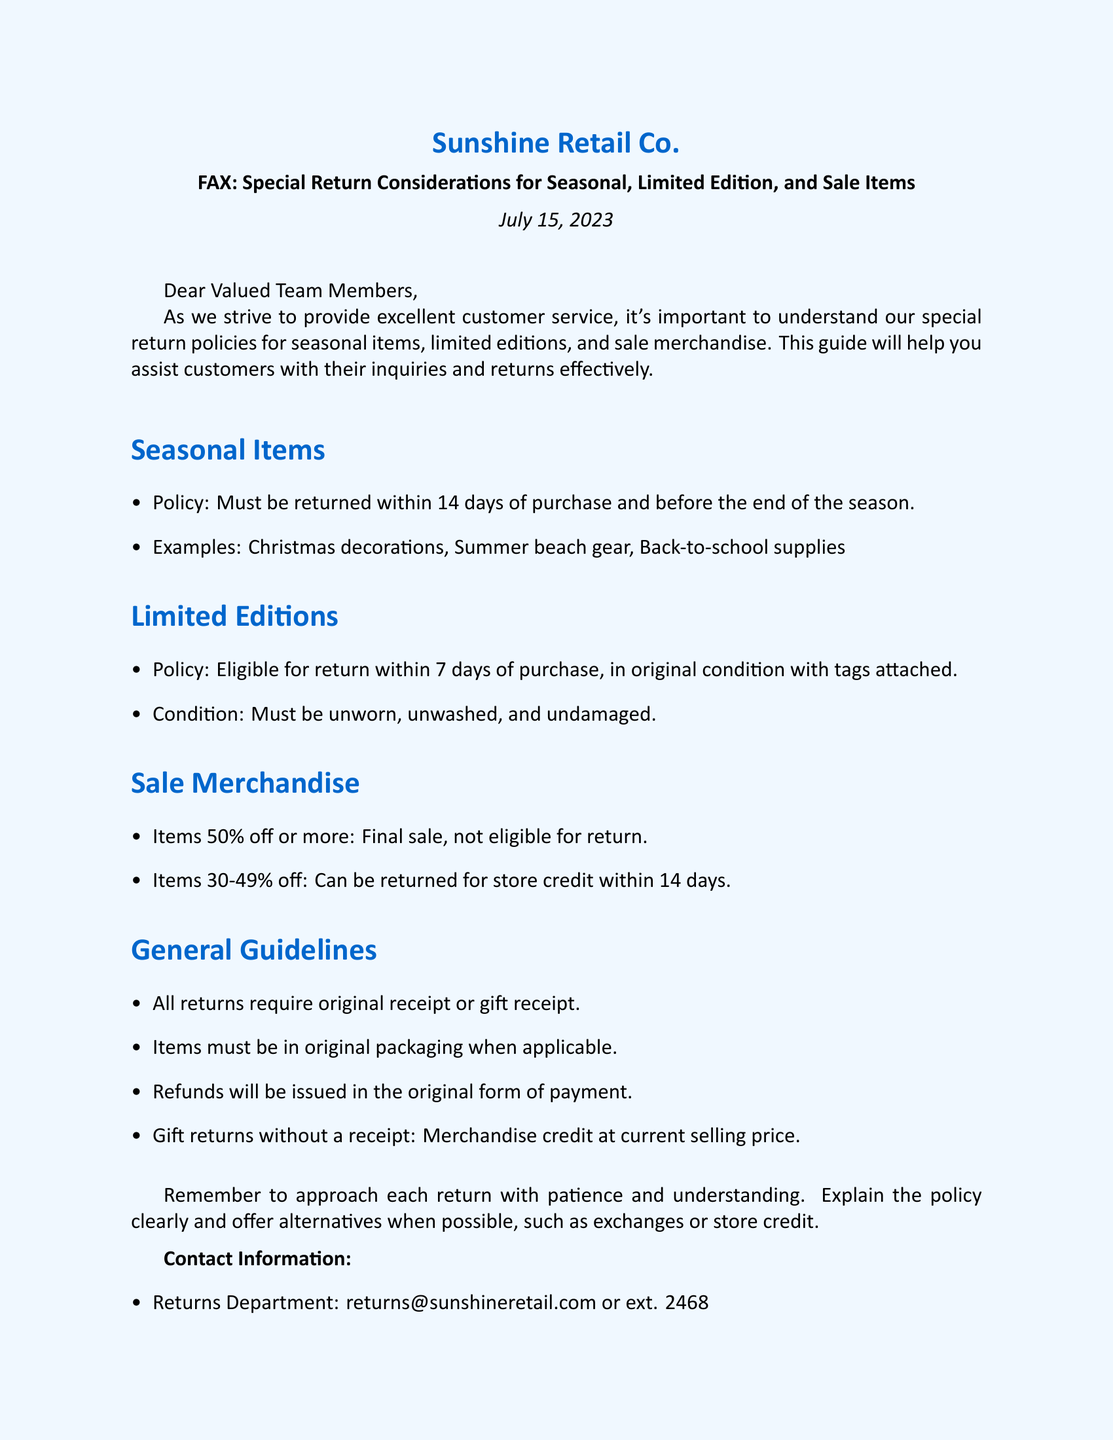What is the return policy for seasonal items? The return policy for seasonal items states that they must be returned within 14 days of purchase and before the end of the season.
Answer: 14 days What condition must limited edition items be in for a return? Limited edition items must be unworn, unwashed, and undamaged to be eligible for return.
Answer: Unworn, unwashed, undamaged What is the return deadline for limited edition items? The deadline for returning limited edition items is within 7 days of purchase.
Answer: 7 days Are items that are 50% off or more eligible for return? Items that are 50% off or more are marked as final sale and are not eligible for return.
Answer: Not eligible What should customers provide for all returns? Customers must provide the original receipt or gift receipt for all returns.
Answer: Original receipt What type of return is offered for items that are 30-49% off? Items that are 30-49% off can be returned for store credit within 14 days.
Answer: Store credit What is the contact information for the returns department? The returns department can be reached at returns@sunshineretail.com or extension 2468.
Answer: returns@sunshineretail.com What is the general guideline for the packaging of return items? Items must be in original packaging when applicable as per the general guidelines.
Answer: Original packaging 